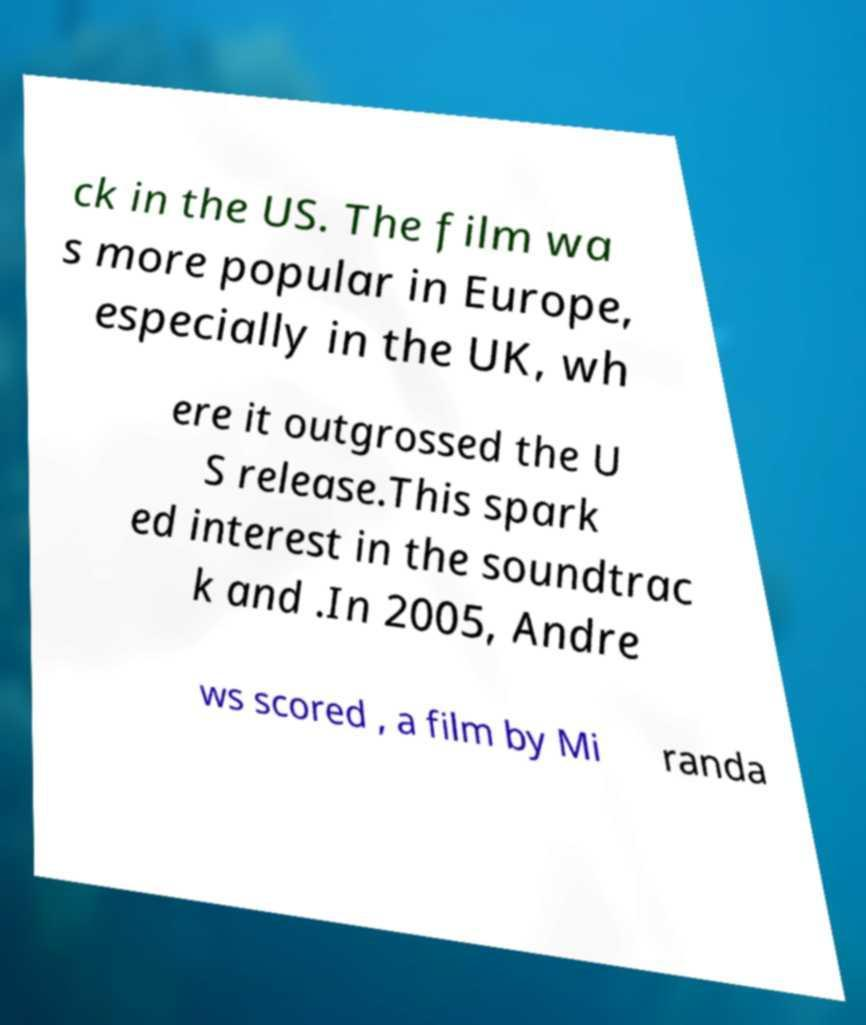Please read and relay the text visible in this image. What does it say? ck in the US. The film wa s more popular in Europe, especially in the UK, wh ere it outgrossed the U S release.This spark ed interest in the soundtrac k and .In 2005, Andre ws scored , a film by Mi randa 